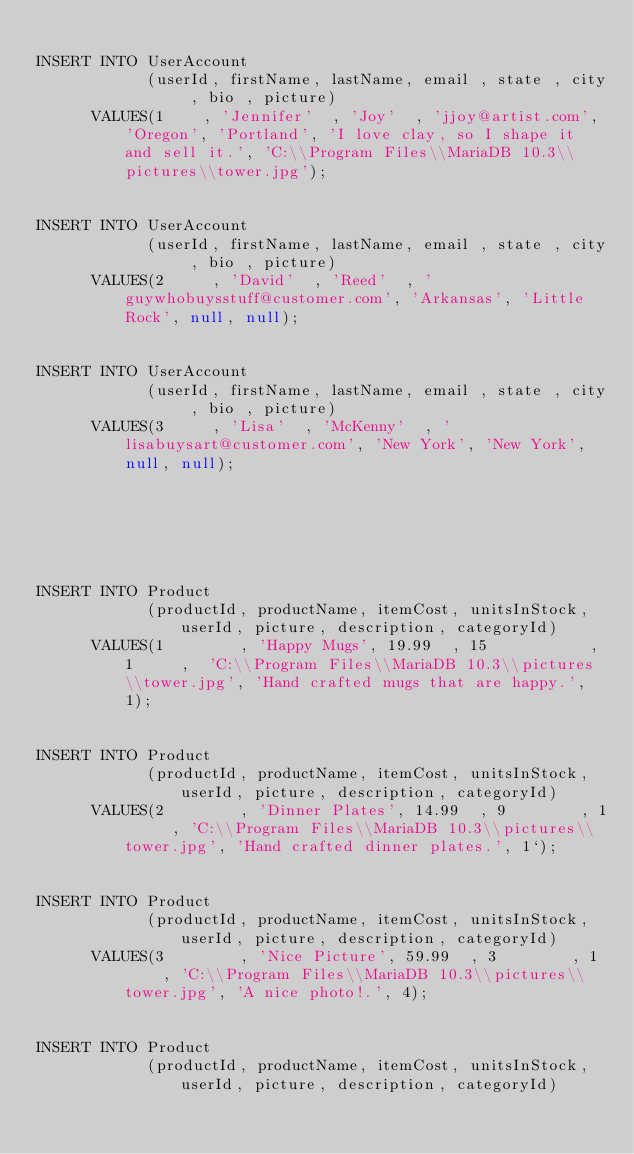Convert code to text. <code><loc_0><loc_0><loc_500><loc_500><_SQL_>
INSERT INTO UserAccount
            (userId, firstName, lastName, email , state , city , bio , picture)
      VALUES(1    , 'Jennifer'  , 'Joy'  , 'jjoy@artist.com', 'Oregon', 'Portland', 'I love clay, so I shape it and sell it.', 'C:\\Program Files\\MariaDB 10.3\\pictures\\tower.jpg');


INSERT INTO UserAccount
            (userId, firstName, lastName, email , state , city , bio , picture)
      VALUES(2     , 'David'  , 'Reed'  , 'guywhobuysstuff@customer.com', 'Arkansas', 'Little Rock', null, null);


INSERT INTO UserAccount
            (userId, firstName, lastName, email , state , city , bio , picture)
      VALUES(3     , 'Lisa'  , 'McKenny'  , 'lisabuysart@customer.com', 'New York', 'New York', null, null);






INSERT INTO Product
            (productId, productName, itemCost, unitsInStock, userId, picture, description, categoryId)
      VALUES(1        , 'Happy Mugs', 19.99  , 15           , 1     ,  'C:\\Program Files\\MariaDB 10.3\\pictures\\tower.jpg', 'Hand crafted mugs that are happy.', 1);


INSERT INTO Product
            (productId, productName, itemCost, unitsInStock, userId, picture, description, categoryId)
      VALUES(2        , 'Dinner Plates', 14.99  , 9        , 1     , 'C:\\Program Files\\MariaDB 10.3\\pictures\\tower.jpg', 'Hand crafted dinner plates.', 1`);


INSERT INTO Product
            (productId, productName, itemCost, unitsInStock, userId, picture, description, categoryId)
      VALUES(3        , 'Nice Picture', 59.99  , 3        , 1     , 'C:\\Program Files\\MariaDB 10.3\\pictures\\tower.jpg', 'A nice photo!.', 4);


INSERT INTO Product
            (productId, productName, itemCost, unitsInStock, userId, picture, description, categoryId)</code> 